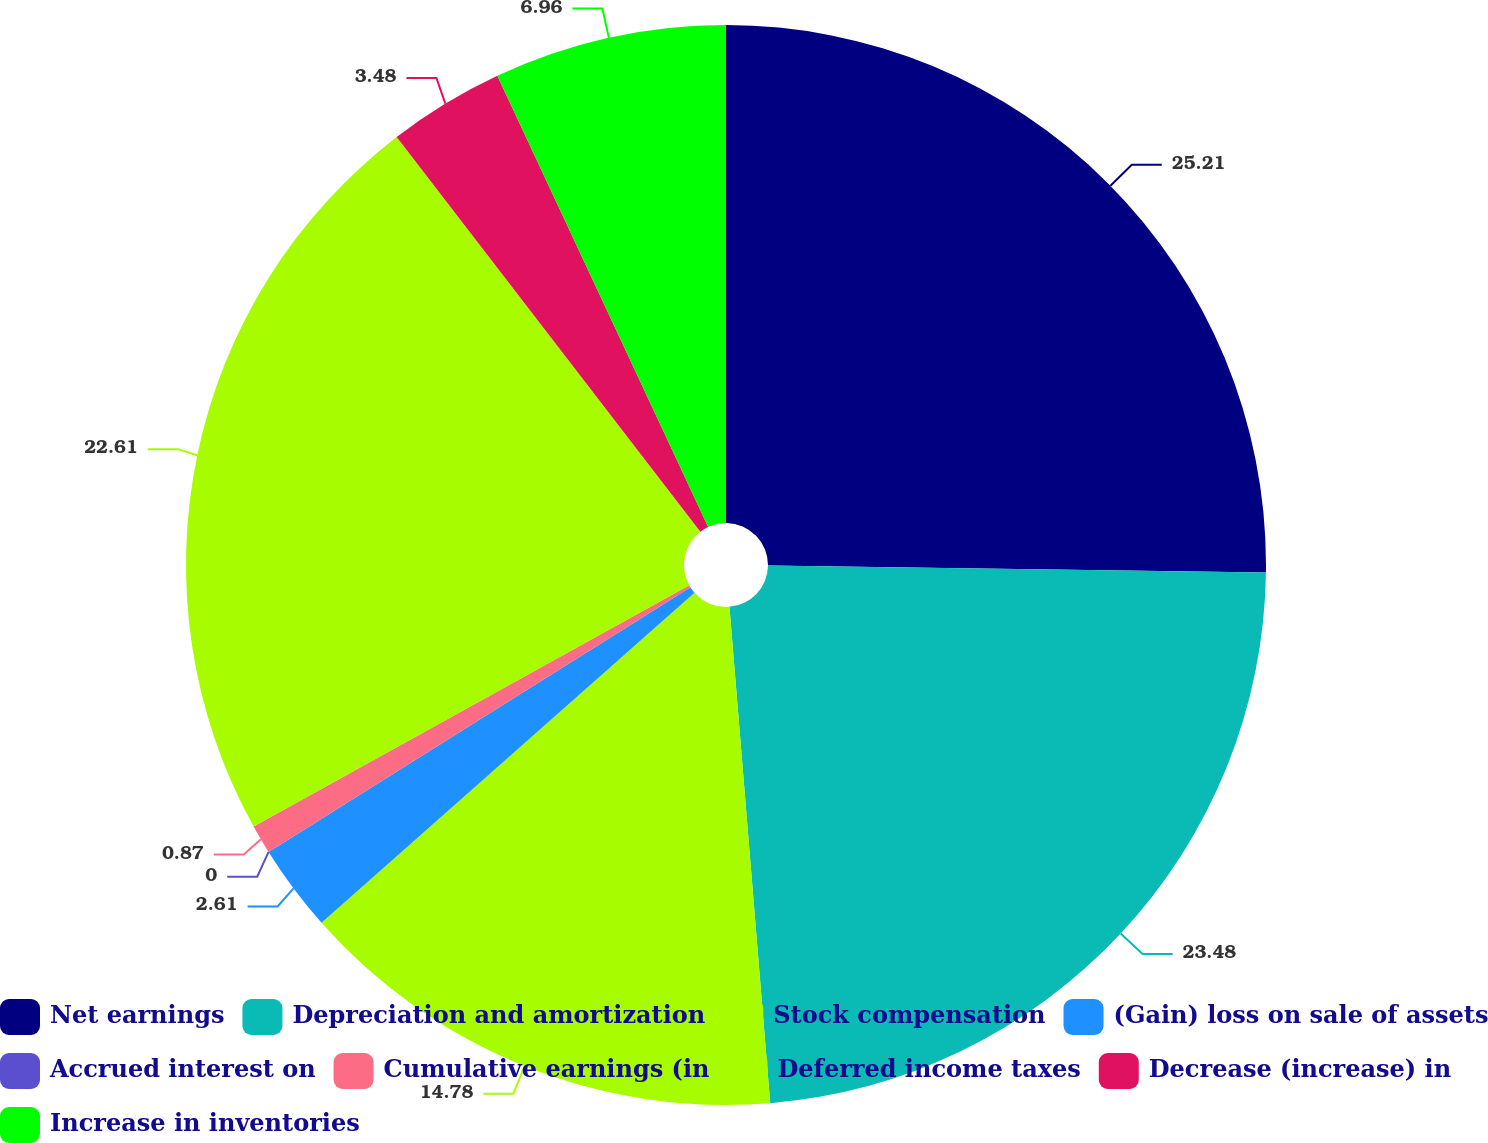<chart> <loc_0><loc_0><loc_500><loc_500><pie_chart><fcel>Net earnings<fcel>Depreciation and amortization<fcel>Stock compensation<fcel>(Gain) loss on sale of assets<fcel>Accrued interest on<fcel>Cumulative earnings (in<fcel>Deferred income taxes<fcel>Decrease (increase) in<fcel>Increase in inventories<nl><fcel>25.22%<fcel>23.48%<fcel>14.78%<fcel>2.61%<fcel>0.0%<fcel>0.87%<fcel>22.61%<fcel>3.48%<fcel>6.96%<nl></chart> 